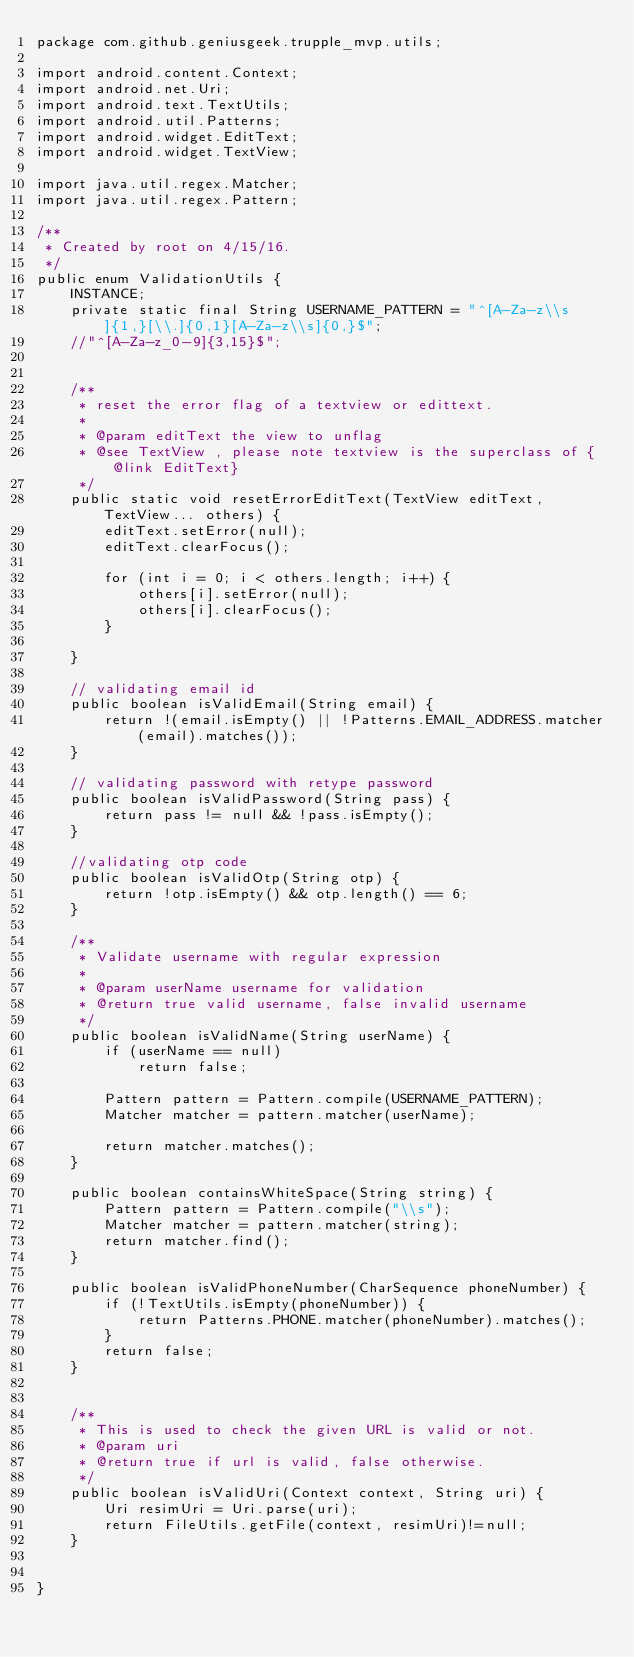<code> <loc_0><loc_0><loc_500><loc_500><_Java_>package com.github.geniusgeek.trupple_mvp.utils;

import android.content.Context;
import android.net.Uri;
import android.text.TextUtils;
import android.util.Patterns;
import android.widget.EditText;
import android.widget.TextView;

import java.util.regex.Matcher;
import java.util.regex.Pattern;

/**
 * Created by root on 4/15/16.
 */
public enum ValidationUtils {
    INSTANCE;
    private static final String USERNAME_PATTERN = "^[A-Za-z\\s]{1,}[\\.]{0,1}[A-Za-z\\s]{0,}$";
    //"^[A-Za-z_0-9]{3,15}$";


    /**
     * reset the error flag of a textview or edittext.
     *
     * @param editText the view to unflag
     * @see TextView , please note textview is the superclass of {@link EditText}
     */
    public static void resetErrorEditText(TextView editText, TextView... others) {
        editText.setError(null);
        editText.clearFocus();

        for (int i = 0; i < others.length; i++) {
            others[i].setError(null);
            others[i].clearFocus();
        }

    }

    // validating email id
    public boolean isValidEmail(String email) {
        return !(email.isEmpty() || !Patterns.EMAIL_ADDRESS.matcher(email).matches());
    }

    // validating password with retype password
    public boolean isValidPassword(String pass) {
        return pass != null && !pass.isEmpty();
    }

    //validating otp code
    public boolean isValidOtp(String otp) {
        return !otp.isEmpty() && otp.length() == 6;
    }

    /**
     * Validate username with regular expression
     *
     * @param userName username for validation
     * @return true valid username, false invalid username
     */
    public boolean isValidName(String userName) {
        if (userName == null)
            return false;

        Pattern pattern = Pattern.compile(USERNAME_PATTERN);
        Matcher matcher = pattern.matcher(userName);

        return matcher.matches();
    }

    public boolean containsWhiteSpace(String string) {
        Pattern pattern = Pattern.compile("\\s");
        Matcher matcher = pattern.matcher(string);
        return matcher.find();
    }

    public boolean isValidPhoneNumber(CharSequence phoneNumber) {
        if (!TextUtils.isEmpty(phoneNumber)) {
            return Patterns.PHONE.matcher(phoneNumber).matches();
        }
        return false;
    }


    /**
     * This is used to check the given URL is valid or not.
     * @param uri
     * @return true if url is valid, false otherwise.
     */
    public boolean isValidUri(Context context, String uri) {
        Uri resimUri = Uri.parse(uri);
        return FileUtils.getFile(context, resimUri)!=null;
    }


}
</code> 